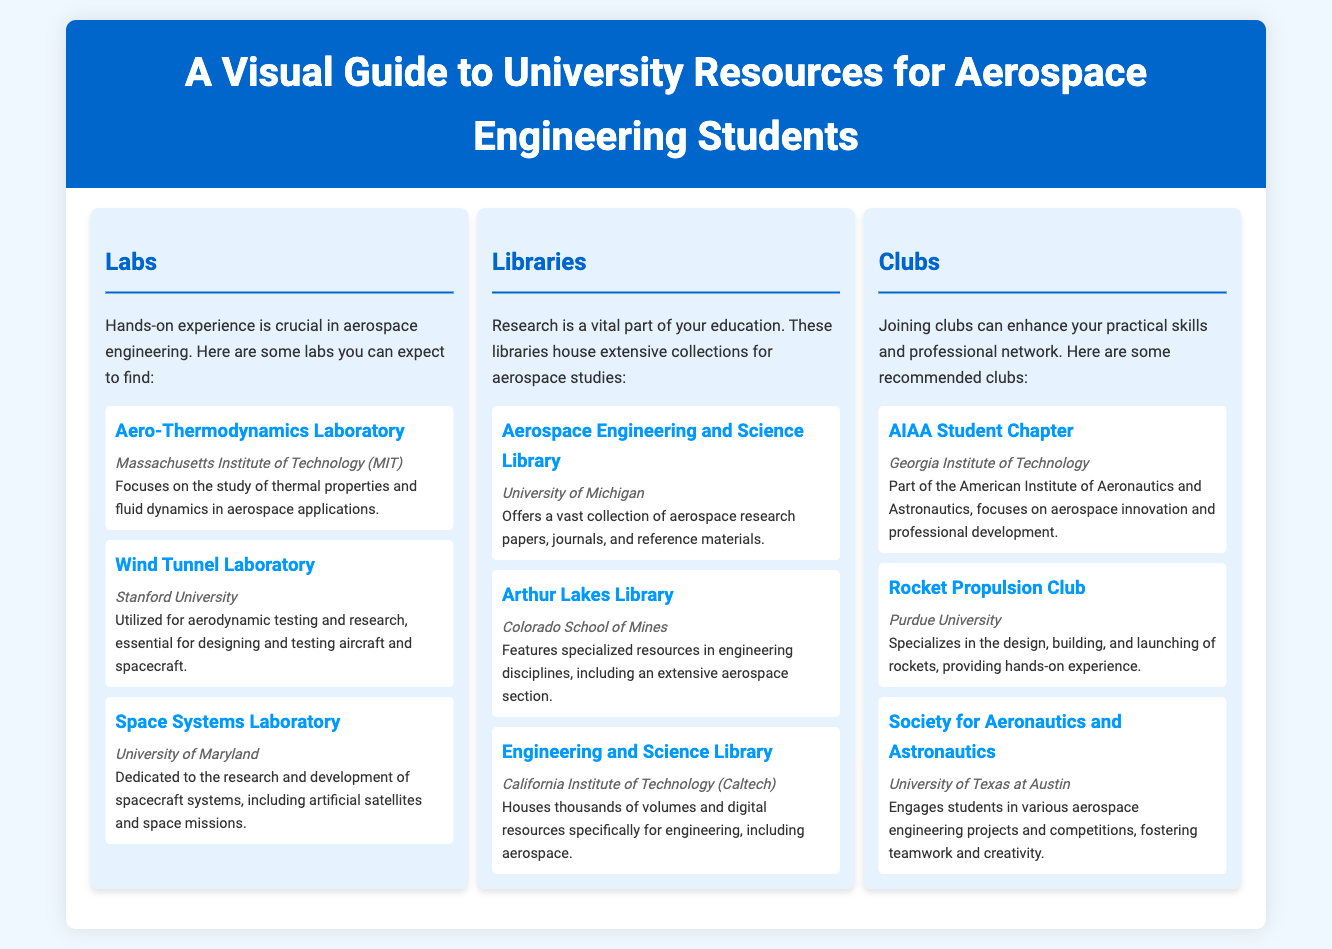What university has the Aero-Thermodynamics Laboratory? The Aero-Thermodynamics Laboratory is located at Massachusetts Institute of Technology.
Answer: Massachusetts Institute of Technology Which club at Georgia Institute of Technology focuses on aerospace innovation? The club that focuses on aerospace innovation at Georgia Institute of Technology is the AIAA Student Chapter.
Answer: AIAA Student Chapter What library houses a vast collection of aerospace research papers at the University of Michigan? The library at the University of Michigan that houses a vast collection of aerospace research papers is the Aerospace Engineering and Science Library.
Answer: Aerospace Engineering and Science Library How many labs are mentioned in the infographic? The infographic lists three labs in total.
Answer: Three Which university features the Rocket Propulsion Club? The Rocket Propulsion Club is associated with Purdue University.
Answer: Purdue University What type of resources does the Arthur Lakes Library specialize in? The Arthur Lakes Library features specialized resources in engineering disciplines, particularly an extensive aerospace section.
Answer: Engineering disciplines Which university's club engages students in various aerospace engineering projects? The society that engages students in various aerospace engineering projects is at the University of Texas at Austin.
Answer: University of Texas at Austin What is the main focus of the Space Systems Laboratory? The main focus of the Space Systems Laboratory is on research and development of spacecraft systems.
Answer: Research and development of spacecraft systems What is emphasized as crucial in aerospace engineering according to the document? The document emphasizes that hands-on experience is crucial in aerospace engineering.
Answer: Hands-on experience 